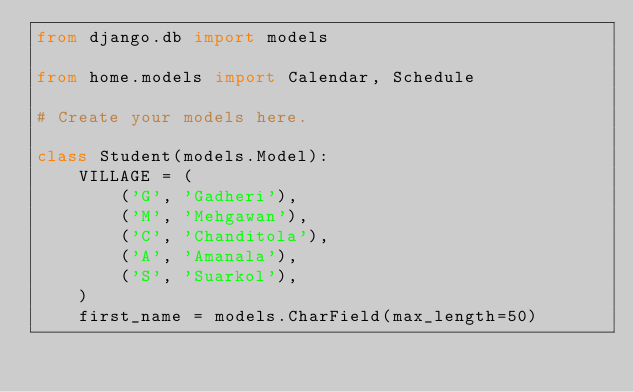Convert code to text. <code><loc_0><loc_0><loc_500><loc_500><_Python_>from django.db import models

from home.models import Calendar, Schedule

# Create your models here.

class Student(models.Model):
    VILLAGE = (
        ('G', 'Gadheri'),
        ('M', 'Mehgawan'),
        ('C', 'Chanditola'),
        ('A', 'Amanala'),
        ('S', 'Suarkol'),
    )
    first_name = models.CharField(max_length=50)</code> 